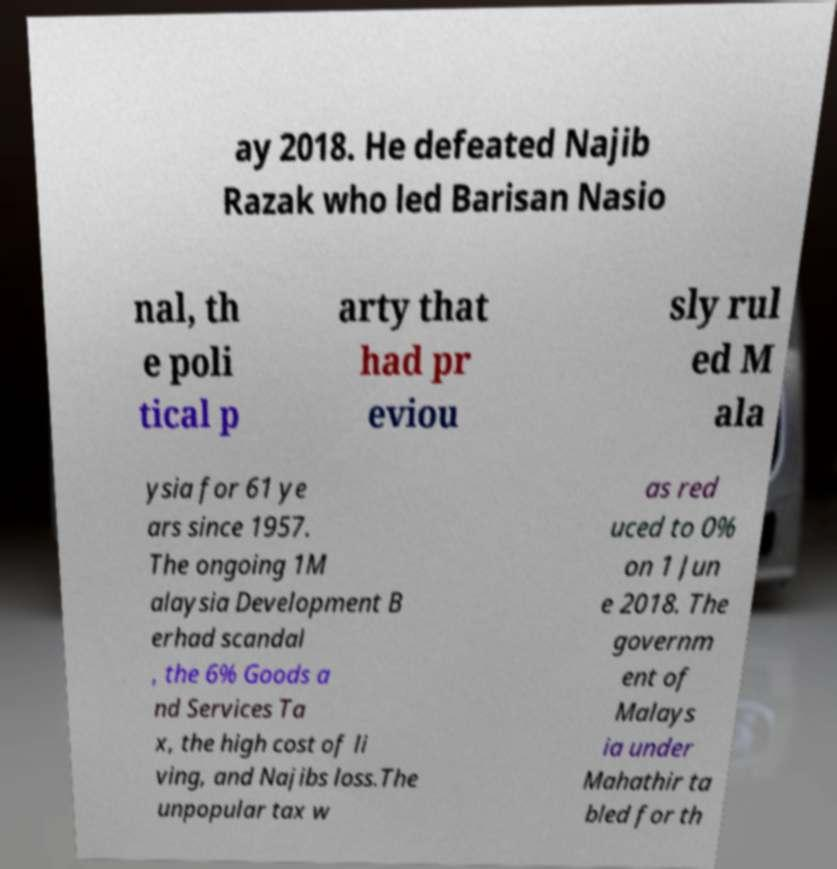Please read and relay the text visible in this image. What does it say? ay 2018. He defeated Najib Razak who led Barisan Nasio nal, th e poli tical p arty that had pr eviou sly rul ed M ala ysia for 61 ye ars since 1957. The ongoing 1M alaysia Development B erhad scandal , the 6% Goods a nd Services Ta x, the high cost of li ving, and Najibs loss.The unpopular tax w as red uced to 0% on 1 Jun e 2018. The governm ent of Malays ia under Mahathir ta bled for th 